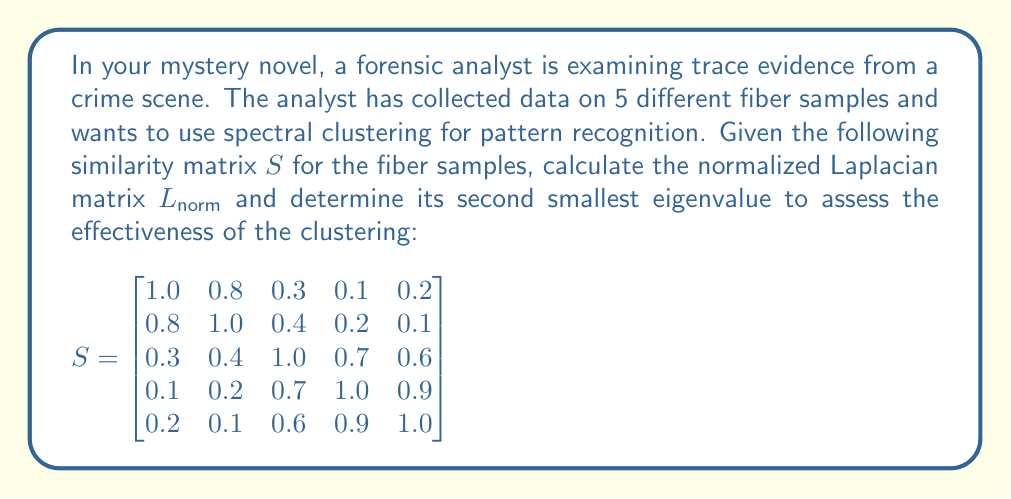What is the answer to this math problem? To solve this problem, we'll follow these steps:

1) Calculate the degree matrix $D$:
   The degree of each node is the sum of its similarities:
   $$D = \text{diag}(2.4, 2.5, 3.0, 2.9, 2.8)$$

2) Calculate the unnormalized Laplacian $L = D - S$:
   $$L = \begin{bmatrix}
   1.4 & -0.8 & -0.3 & -0.1 & -0.2 \\
   -0.8 & 1.5 & -0.4 & -0.2 & -0.1 \\
   -0.3 & -0.4 & 2.0 & -0.7 & -0.6 \\
   -0.1 & -0.2 & -0.7 & 1.9 & -0.9 \\
   -0.2 & -0.1 & -0.6 & -0.9 & 1.8
   \end{bmatrix}$$

3) Calculate the normalized Laplacian $L_{norm} = D^{-1/2}LD^{-1/2}$:
   $$L_{norm} = \begin{bmatrix}
   1 & -0.424 & -0.145 & -0.049 & -0.100 \\
   -0.424 & 1 & -0.189 & -0.096 & -0.049 \\
   -0.145 & -0.189 & 1 & -0.355 & -0.310 \\
   -0.049 & -0.096 & -0.355 & 1 & -0.490 \\
   -0.100 & -0.049 & -0.310 & -0.490 & 1
   \end{bmatrix}$$

4) Calculate the eigenvalues of $L_{norm}$:
   Using a numerical method (e.g., QR algorithm), we find the eigenvalues:
   $\lambda_1 \approx 0$, $\lambda_2 \approx 0.2087$, $\lambda_3 \approx 0.3919$, $\lambda_4 \approx 1.1994$, $\lambda_5 \approx 2.2000$

5) The second smallest eigenvalue is $\lambda_2 \approx 0.2087$.

The second smallest eigenvalue, also known as the algebraic connectivity, provides information about the graph's structure. A small value (close to 0) indicates that the graph can be easily divided into clusters, while a larger value suggests a more connected graph.
Answer: $\lambda_2 \approx 0.2087$ 